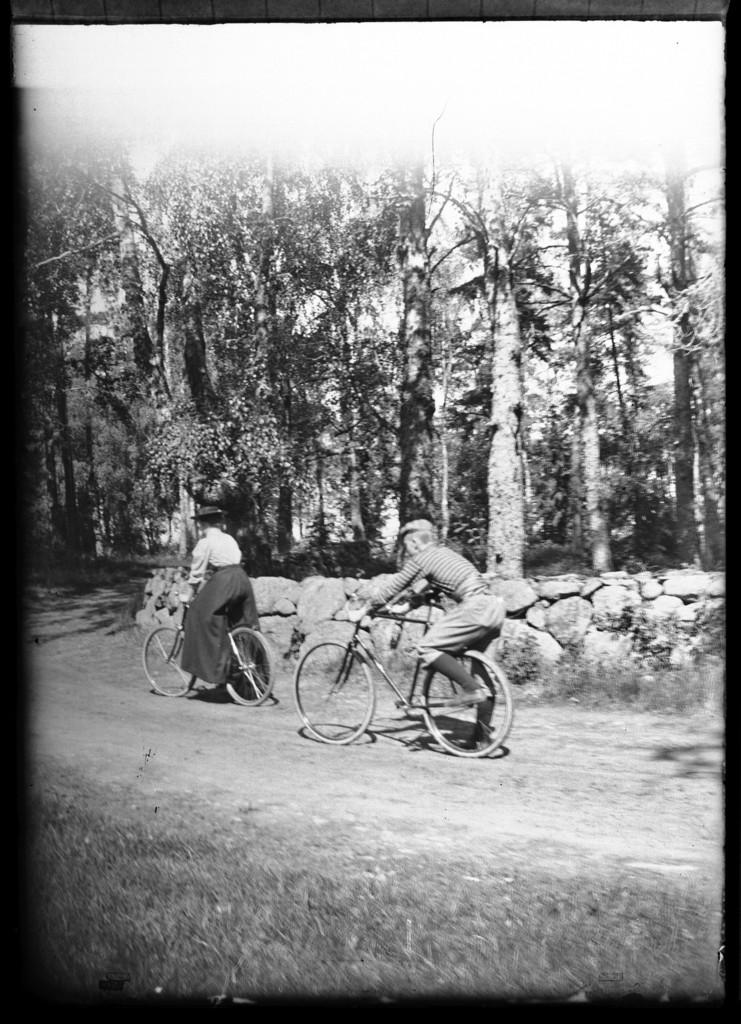How many people are in the image? There are two persons in the image. What are the two persons doing in the image? The two persons are riding a bicycle. What can be seen in the background of the image? There are rocks and trees in the background of the image. What type of jewel can be seen on the bicycle in the image? There is no jewel present on the bicycle in the image. 